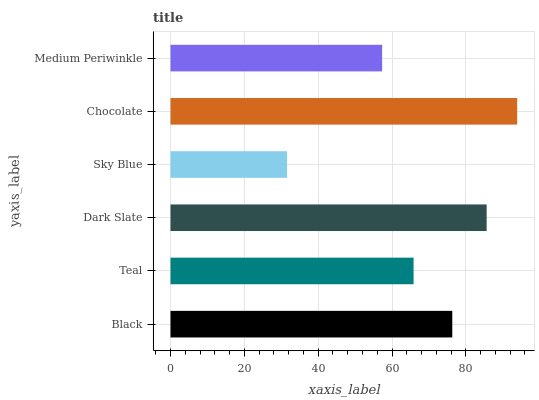Is Sky Blue the minimum?
Answer yes or no. Yes. Is Chocolate the maximum?
Answer yes or no. Yes. Is Teal the minimum?
Answer yes or no. No. Is Teal the maximum?
Answer yes or no. No. Is Black greater than Teal?
Answer yes or no. Yes. Is Teal less than Black?
Answer yes or no. Yes. Is Teal greater than Black?
Answer yes or no. No. Is Black less than Teal?
Answer yes or no. No. Is Black the high median?
Answer yes or no. Yes. Is Teal the low median?
Answer yes or no. Yes. Is Sky Blue the high median?
Answer yes or no. No. Is Sky Blue the low median?
Answer yes or no. No. 